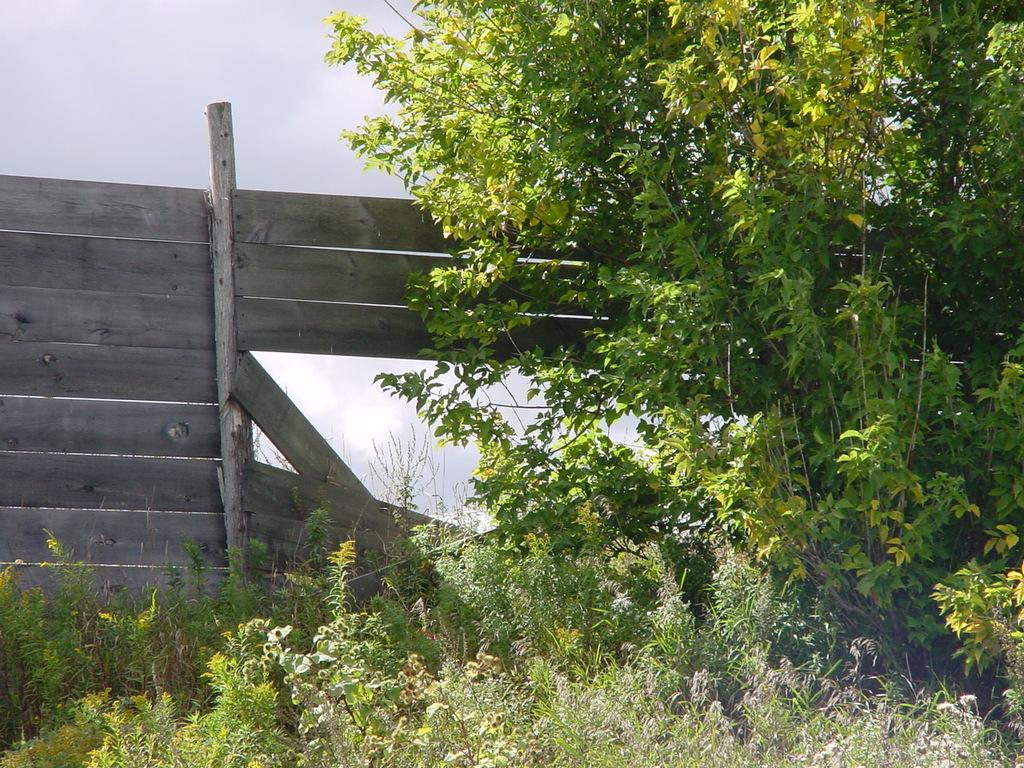What type of vegetation is present in the image? There is a tree and plants in the image. What material are the planks made of in the image? The wooden planks in the image are made of wood. What can be seen in the background of the image? The sky is visible in the background of the image. How many babies are playing with the wooden planks in the image? There are no babies present in the image, and therefore no such activity can be observed. What type of club is visible in the image? There is no club visible in the image. 